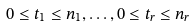Convert formula to latex. <formula><loc_0><loc_0><loc_500><loc_500>0 \leq t _ { 1 } \leq n _ { 1 } , \dots , 0 \leq t _ { r } \leq n _ { r }</formula> 